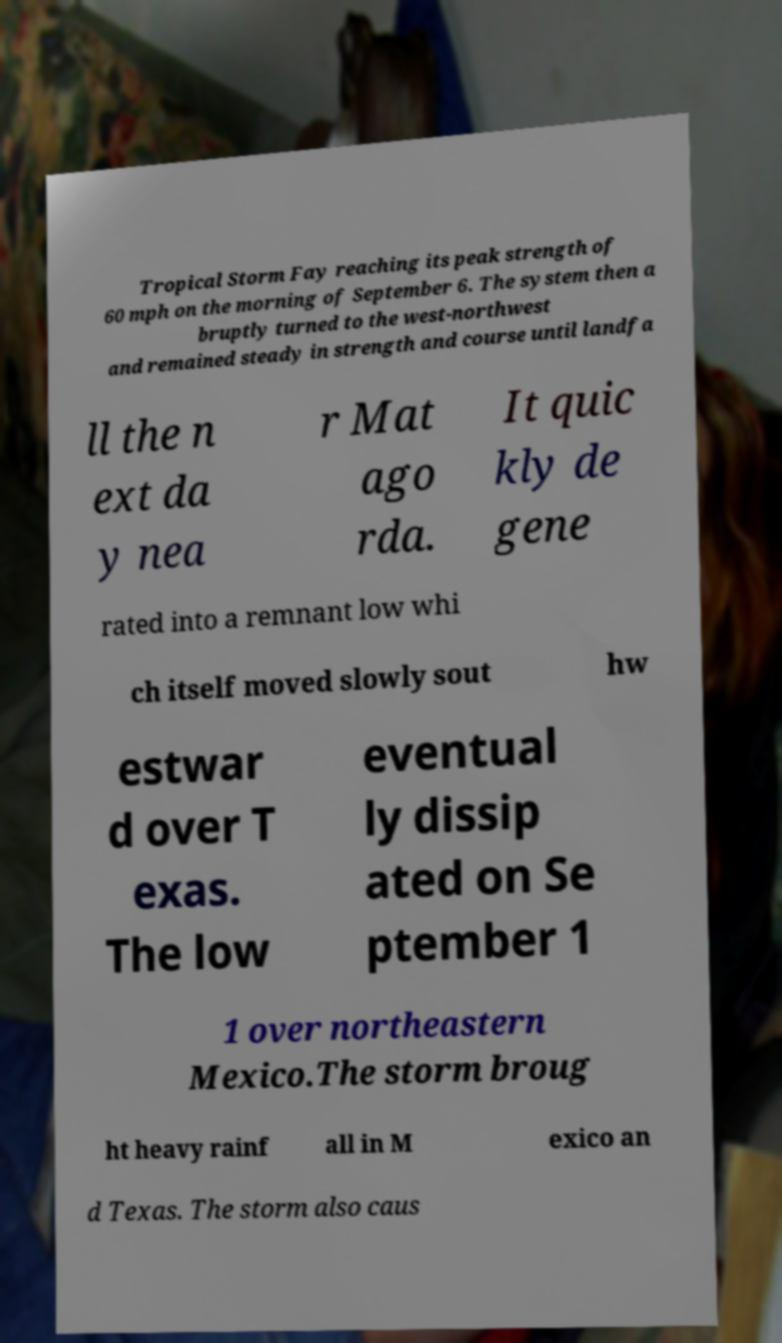Can you accurately transcribe the text from the provided image for me? Tropical Storm Fay reaching its peak strength of 60 mph on the morning of September 6. The system then a bruptly turned to the west-northwest and remained steady in strength and course until landfa ll the n ext da y nea r Mat ago rda. It quic kly de gene rated into a remnant low whi ch itself moved slowly sout hw estwar d over T exas. The low eventual ly dissip ated on Se ptember 1 1 over northeastern Mexico.The storm broug ht heavy rainf all in M exico an d Texas. The storm also caus 